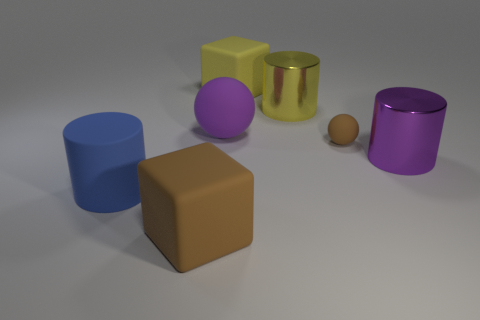Are there any other things that are the same material as the yellow cylinder?
Provide a short and direct response. Yes. Is the number of big purple metallic cylinders that are on the left side of the yellow rubber block less than the number of small brown things?
Your answer should be very brief. Yes. What material is the big cube that is in front of the big metal object in front of the yellow metal cylinder?
Offer a terse response. Rubber. There is a large rubber object that is both in front of the small matte thing and behind the big brown matte thing; what shape is it?
Your answer should be very brief. Cylinder. How many other objects are the same color as the large rubber cylinder?
Provide a succinct answer. 0. What number of objects are big things that are in front of the purple ball or big red shiny cylinders?
Your answer should be very brief. 3. Does the tiny ball have the same color as the block in front of the large purple shiny object?
Give a very brief answer. Yes. Is there anything else that is the same size as the blue matte object?
Ensure brevity in your answer.  Yes. How big is the purple object that is to the left of the yellow rubber block that is behind the purple metal object?
Keep it short and to the point. Large. How many objects are tiny rubber things or big cylinders that are right of the yellow rubber object?
Provide a short and direct response. 3. 